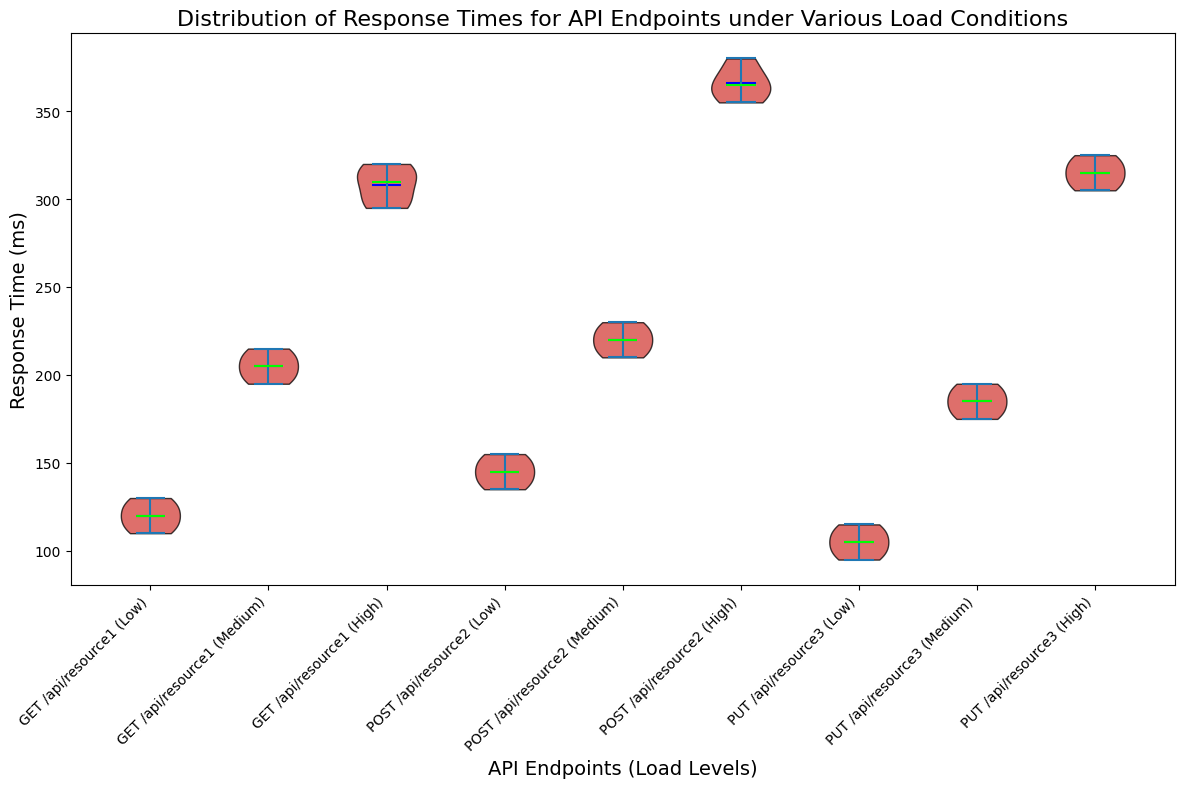Which endpoint has the highest response time under high load? To find the endpoint with the highest response time under high load, compare the positions of the highest points in the violins corresponding to the "High" load for each endpoint. The POST /api/resource2 endpoint has the highest peaks.
Answer: POST /api/resource2 How do the median response times of GET /api/resource1 compare under the different load conditions? Look at the lime lines (medians) for GET /api/resource1 under Low, Medium, and High loads. The median values increase progressively from Low to High.
Answer: Low < Medium < High Which endpoint has the smallest spread in response times under low load? To identify the endpoint with the smallest spread under low load, compare the width of the violins for the Low load of each endpoint. PUT /api/resource3 has the smallest spread.
Answer: PUT /api/resource3 What is the difference between the mean response times for POST /api/resource2 under low and high load? Look at the blue lines (means) for POST /api/resource2 under Low and High loads. Estimate the values, and compute the difference. Roughly, mean for Low is 145 and High is 366. Difference = 366 - 145.
Answer: 221 Under medium load, which endpoint has the highest median response time and what is its value? Look at the lime lines for the endpoints under Medium load. Identify the endpoint with the highest lime line, which is POST /api/resource2. Estimate its value, which appears to be approximately 225ms.
Answer: POST /api/resource2, 225ms How does the variation in response times for PUT /api/resource3 under high load compare to that under low load? Compare the widths and heights of the violins for PUT /api/resource3 under High and Low loads. The High load shows a larger spread and generally higher values than Low.
Answer: Higher and wider in High load What is the mean response time for GET /api/resource1 under medium load? Find the blue line (mean) in the violin for GET /api/resource1 under Medium load. Estimate the value, which is around 205ms.
Answer: 205ms Which endpoint has the most consistent response time regardless of load? Compare the spread and the consistency of the patterns of all the violins across Low, Medium, and High loads. GET /api/resource1 shows the most consistency.
Answer: GET /api/resource1 